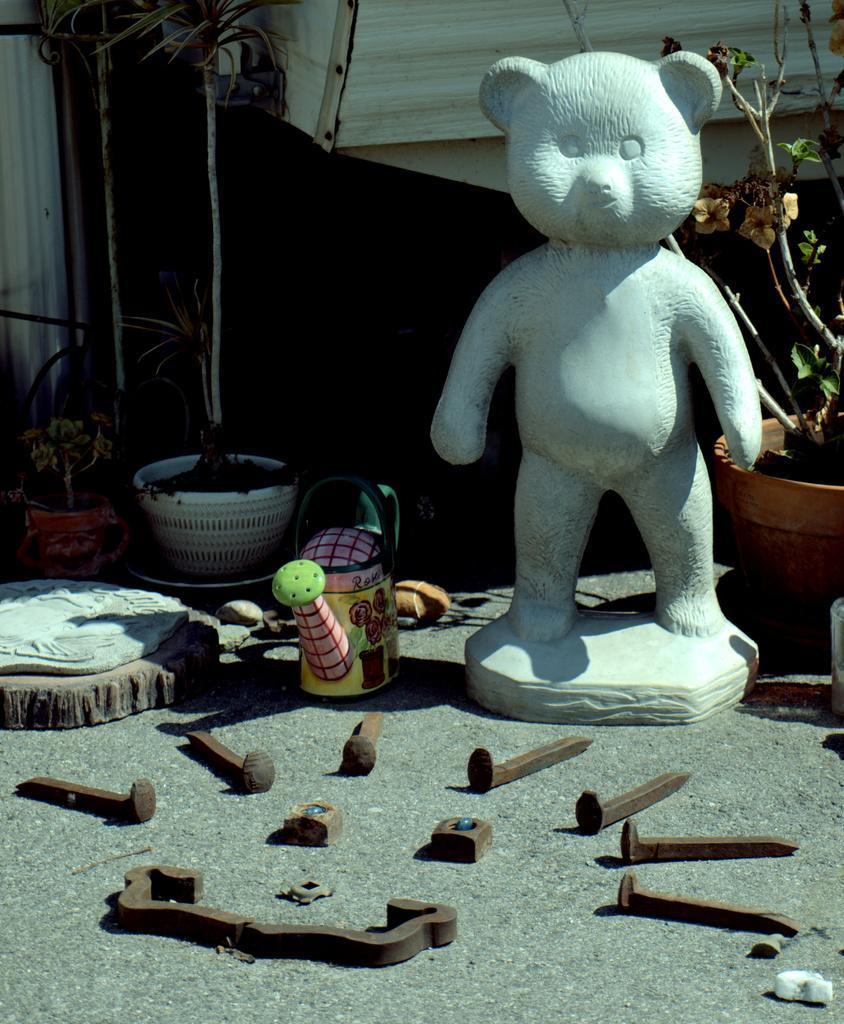Please provide a concise description of this image. In this picture we can observe a statue on the right side which is in white color. There are some tools which were used to make a statue. On the right side there is a plant in the plant pot which is in brown color. We can observe some plants in this picture. In the background there is a black color cloth. 